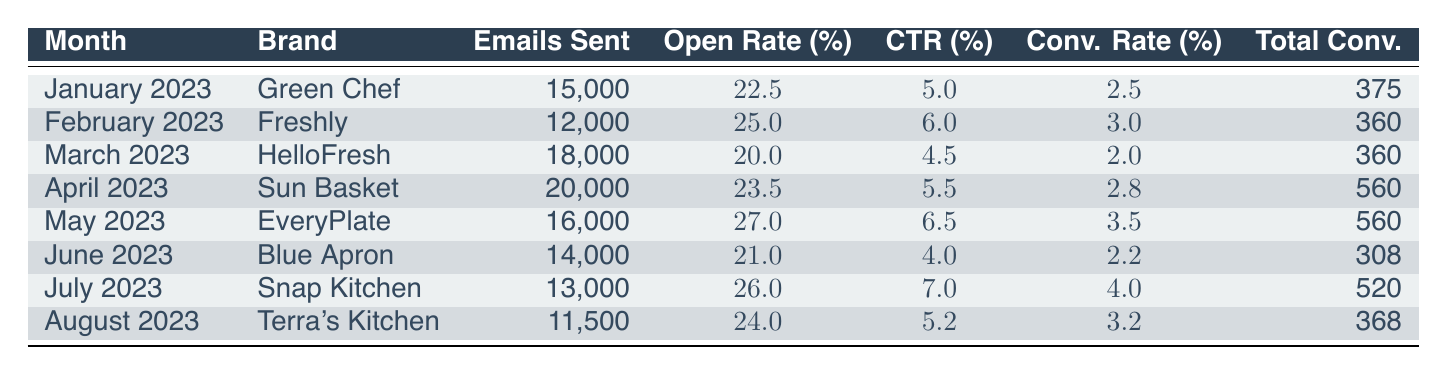What was the conversion rate for EveryPlate in May 2023? The table shows that EveryPlate had a conversion rate of 3.5% in May 2023.
Answer: 3.5% Which brand had the highest total conversions in April 2023? In April 2023, Sun Basket had the highest total conversions, with 560 conversions listed in the table.
Answer: Sun Basket What is the average open rate across all campaigns? To find the average open rate, sum all open rates (22.5 + 25.0 + 20.0 + 23.5 + 27.0 + 21.0 + 26.0 + 24.0 =  189) and then divide by the number of campaigns (8). The average open rate is 189/8 = 23.625%.
Answer: 23.63% Did HelloFresh achieve a conversion rate higher than 2% in March 2023? The table indicates that HelloFresh had a conversion rate of 2.0% in March 2023, which is not higher than 2%.
Answer: No Which month had the lowest click-through rate among the campaigns? Reviewing the click-through rates by month, Blue Apron in June 2023 had the lowest click-through rate at 4.0%.
Answer: June 2023 